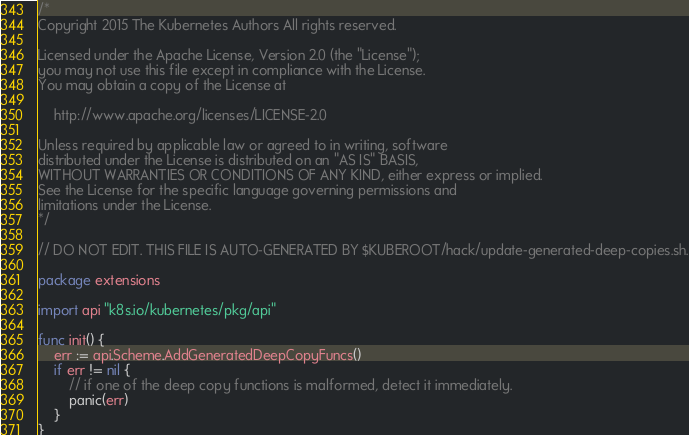Convert code to text. <code><loc_0><loc_0><loc_500><loc_500><_Go_>/*
Copyright 2015 The Kubernetes Authors All rights reserved.

Licensed under the Apache License, Version 2.0 (the "License");
you may not use this file except in compliance with the License.
You may obtain a copy of the License at

    http://www.apache.org/licenses/LICENSE-2.0

Unless required by applicable law or agreed to in writing, software
distributed under the License is distributed on an "AS IS" BASIS,
WITHOUT WARRANTIES OR CONDITIONS OF ANY KIND, either express or implied.
See the License for the specific language governing permissions and
limitations under the License.
*/

// DO NOT EDIT. THIS FILE IS AUTO-GENERATED BY $KUBEROOT/hack/update-generated-deep-copies.sh.

package extensions

import api "k8s.io/kubernetes/pkg/api"

func init() {
	err := api.Scheme.AddGeneratedDeepCopyFuncs()
	if err != nil {
		// if one of the deep copy functions is malformed, detect it immediately.
		panic(err)
	}
}
</code> 